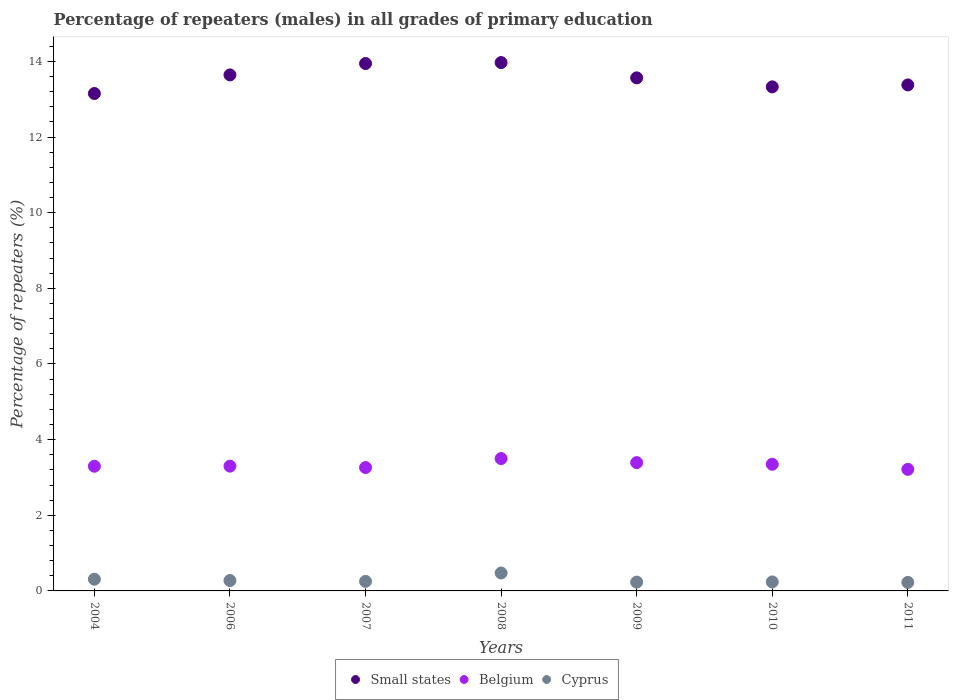What is the percentage of repeaters (males) in Cyprus in 2009?
Offer a very short reply. 0.23. Across all years, what is the maximum percentage of repeaters (males) in Cyprus?
Make the answer very short. 0.47. Across all years, what is the minimum percentage of repeaters (males) in Belgium?
Ensure brevity in your answer.  3.21. In which year was the percentage of repeaters (males) in Belgium maximum?
Offer a terse response. 2008. In which year was the percentage of repeaters (males) in Belgium minimum?
Offer a very short reply. 2011. What is the total percentage of repeaters (males) in Small states in the graph?
Your answer should be very brief. 94.98. What is the difference between the percentage of repeaters (males) in Small states in 2007 and that in 2011?
Your answer should be compact. 0.57. What is the difference between the percentage of repeaters (males) in Cyprus in 2011 and the percentage of repeaters (males) in Belgium in 2009?
Your response must be concise. -3.17. What is the average percentage of repeaters (males) in Cyprus per year?
Offer a terse response. 0.29. In the year 2011, what is the difference between the percentage of repeaters (males) in Cyprus and percentage of repeaters (males) in Belgium?
Give a very brief answer. -2.99. What is the ratio of the percentage of repeaters (males) in Small states in 2004 to that in 2008?
Give a very brief answer. 0.94. What is the difference between the highest and the second highest percentage of repeaters (males) in Belgium?
Ensure brevity in your answer.  0.11. What is the difference between the highest and the lowest percentage of repeaters (males) in Small states?
Offer a very short reply. 0.82. In how many years, is the percentage of repeaters (males) in Belgium greater than the average percentage of repeaters (males) in Belgium taken over all years?
Your response must be concise. 3. Is the sum of the percentage of repeaters (males) in Belgium in 2008 and 2011 greater than the maximum percentage of repeaters (males) in Cyprus across all years?
Offer a very short reply. Yes. Does the percentage of repeaters (males) in Belgium monotonically increase over the years?
Your response must be concise. No. Is the percentage of repeaters (males) in Small states strictly less than the percentage of repeaters (males) in Belgium over the years?
Provide a succinct answer. No. What is the difference between two consecutive major ticks on the Y-axis?
Offer a very short reply. 2. Are the values on the major ticks of Y-axis written in scientific E-notation?
Ensure brevity in your answer.  No. Does the graph contain any zero values?
Ensure brevity in your answer.  No. What is the title of the graph?
Offer a terse response. Percentage of repeaters (males) in all grades of primary education. Does "Mauritania" appear as one of the legend labels in the graph?
Your response must be concise. No. What is the label or title of the Y-axis?
Your answer should be compact. Percentage of repeaters (%). What is the Percentage of repeaters (%) of Small states in 2004?
Your answer should be very brief. 13.15. What is the Percentage of repeaters (%) in Belgium in 2004?
Provide a succinct answer. 3.3. What is the Percentage of repeaters (%) of Cyprus in 2004?
Your answer should be compact. 0.31. What is the Percentage of repeaters (%) of Small states in 2006?
Offer a terse response. 13.64. What is the Percentage of repeaters (%) of Belgium in 2006?
Make the answer very short. 3.3. What is the Percentage of repeaters (%) of Cyprus in 2006?
Provide a short and direct response. 0.27. What is the Percentage of repeaters (%) in Small states in 2007?
Provide a succinct answer. 13.94. What is the Percentage of repeaters (%) of Belgium in 2007?
Your answer should be compact. 3.26. What is the Percentage of repeaters (%) in Cyprus in 2007?
Offer a terse response. 0.25. What is the Percentage of repeaters (%) in Small states in 2008?
Your answer should be very brief. 13.97. What is the Percentage of repeaters (%) of Belgium in 2008?
Ensure brevity in your answer.  3.5. What is the Percentage of repeaters (%) in Cyprus in 2008?
Your answer should be very brief. 0.47. What is the Percentage of repeaters (%) of Small states in 2009?
Offer a very short reply. 13.57. What is the Percentage of repeaters (%) of Belgium in 2009?
Provide a short and direct response. 3.39. What is the Percentage of repeaters (%) of Cyprus in 2009?
Your response must be concise. 0.23. What is the Percentage of repeaters (%) of Small states in 2010?
Your answer should be very brief. 13.33. What is the Percentage of repeaters (%) in Belgium in 2010?
Your answer should be compact. 3.35. What is the Percentage of repeaters (%) of Cyprus in 2010?
Provide a short and direct response. 0.24. What is the Percentage of repeaters (%) of Small states in 2011?
Give a very brief answer. 13.38. What is the Percentage of repeaters (%) in Belgium in 2011?
Offer a very short reply. 3.21. What is the Percentage of repeaters (%) in Cyprus in 2011?
Your answer should be very brief. 0.23. Across all years, what is the maximum Percentage of repeaters (%) in Small states?
Your answer should be very brief. 13.97. Across all years, what is the maximum Percentage of repeaters (%) of Belgium?
Offer a terse response. 3.5. Across all years, what is the maximum Percentage of repeaters (%) in Cyprus?
Your answer should be very brief. 0.47. Across all years, what is the minimum Percentage of repeaters (%) of Small states?
Ensure brevity in your answer.  13.15. Across all years, what is the minimum Percentage of repeaters (%) in Belgium?
Provide a succinct answer. 3.21. Across all years, what is the minimum Percentage of repeaters (%) of Cyprus?
Ensure brevity in your answer.  0.23. What is the total Percentage of repeaters (%) in Small states in the graph?
Ensure brevity in your answer.  94.98. What is the total Percentage of repeaters (%) of Belgium in the graph?
Offer a very short reply. 23.31. What is the total Percentage of repeaters (%) in Cyprus in the graph?
Give a very brief answer. 2.01. What is the difference between the Percentage of repeaters (%) in Small states in 2004 and that in 2006?
Keep it short and to the point. -0.49. What is the difference between the Percentage of repeaters (%) in Belgium in 2004 and that in 2006?
Provide a short and direct response. -0. What is the difference between the Percentage of repeaters (%) in Cyprus in 2004 and that in 2006?
Give a very brief answer. 0.04. What is the difference between the Percentage of repeaters (%) in Small states in 2004 and that in 2007?
Make the answer very short. -0.79. What is the difference between the Percentage of repeaters (%) in Belgium in 2004 and that in 2007?
Give a very brief answer. 0.03. What is the difference between the Percentage of repeaters (%) in Cyprus in 2004 and that in 2007?
Ensure brevity in your answer.  0.06. What is the difference between the Percentage of repeaters (%) of Small states in 2004 and that in 2008?
Give a very brief answer. -0.82. What is the difference between the Percentage of repeaters (%) of Belgium in 2004 and that in 2008?
Provide a short and direct response. -0.2. What is the difference between the Percentage of repeaters (%) of Cyprus in 2004 and that in 2008?
Provide a succinct answer. -0.16. What is the difference between the Percentage of repeaters (%) of Small states in 2004 and that in 2009?
Offer a very short reply. -0.41. What is the difference between the Percentage of repeaters (%) of Belgium in 2004 and that in 2009?
Provide a succinct answer. -0.1. What is the difference between the Percentage of repeaters (%) in Cyprus in 2004 and that in 2009?
Keep it short and to the point. 0.08. What is the difference between the Percentage of repeaters (%) in Small states in 2004 and that in 2010?
Provide a short and direct response. -0.18. What is the difference between the Percentage of repeaters (%) of Belgium in 2004 and that in 2010?
Offer a terse response. -0.05. What is the difference between the Percentage of repeaters (%) of Cyprus in 2004 and that in 2010?
Offer a terse response. 0.07. What is the difference between the Percentage of repeaters (%) in Small states in 2004 and that in 2011?
Your answer should be compact. -0.23. What is the difference between the Percentage of repeaters (%) in Belgium in 2004 and that in 2011?
Your response must be concise. 0.08. What is the difference between the Percentage of repeaters (%) of Cyprus in 2004 and that in 2011?
Your answer should be very brief. 0.08. What is the difference between the Percentage of repeaters (%) of Small states in 2006 and that in 2007?
Offer a terse response. -0.3. What is the difference between the Percentage of repeaters (%) in Belgium in 2006 and that in 2007?
Give a very brief answer. 0.04. What is the difference between the Percentage of repeaters (%) of Cyprus in 2006 and that in 2007?
Make the answer very short. 0.02. What is the difference between the Percentage of repeaters (%) in Small states in 2006 and that in 2008?
Give a very brief answer. -0.33. What is the difference between the Percentage of repeaters (%) in Belgium in 2006 and that in 2008?
Your response must be concise. -0.2. What is the difference between the Percentage of repeaters (%) in Cyprus in 2006 and that in 2008?
Provide a short and direct response. -0.2. What is the difference between the Percentage of repeaters (%) of Small states in 2006 and that in 2009?
Give a very brief answer. 0.08. What is the difference between the Percentage of repeaters (%) of Belgium in 2006 and that in 2009?
Your answer should be very brief. -0.09. What is the difference between the Percentage of repeaters (%) of Cyprus in 2006 and that in 2009?
Your answer should be very brief. 0.04. What is the difference between the Percentage of repeaters (%) in Small states in 2006 and that in 2010?
Ensure brevity in your answer.  0.32. What is the difference between the Percentage of repeaters (%) in Belgium in 2006 and that in 2010?
Keep it short and to the point. -0.05. What is the difference between the Percentage of repeaters (%) of Cyprus in 2006 and that in 2010?
Make the answer very short. 0.04. What is the difference between the Percentage of repeaters (%) in Small states in 2006 and that in 2011?
Provide a succinct answer. 0.27. What is the difference between the Percentage of repeaters (%) of Belgium in 2006 and that in 2011?
Give a very brief answer. 0.08. What is the difference between the Percentage of repeaters (%) of Cyprus in 2006 and that in 2011?
Provide a short and direct response. 0.05. What is the difference between the Percentage of repeaters (%) in Small states in 2007 and that in 2008?
Offer a very short reply. -0.03. What is the difference between the Percentage of repeaters (%) in Belgium in 2007 and that in 2008?
Ensure brevity in your answer.  -0.24. What is the difference between the Percentage of repeaters (%) of Cyprus in 2007 and that in 2008?
Your response must be concise. -0.22. What is the difference between the Percentage of repeaters (%) of Small states in 2007 and that in 2009?
Provide a succinct answer. 0.38. What is the difference between the Percentage of repeaters (%) in Belgium in 2007 and that in 2009?
Keep it short and to the point. -0.13. What is the difference between the Percentage of repeaters (%) in Cyprus in 2007 and that in 2009?
Your answer should be compact. 0.02. What is the difference between the Percentage of repeaters (%) of Small states in 2007 and that in 2010?
Give a very brief answer. 0.62. What is the difference between the Percentage of repeaters (%) of Belgium in 2007 and that in 2010?
Your response must be concise. -0.09. What is the difference between the Percentage of repeaters (%) in Cyprus in 2007 and that in 2010?
Provide a succinct answer. 0.01. What is the difference between the Percentage of repeaters (%) of Small states in 2007 and that in 2011?
Your answer should be very brief. 0.57. What is the difference between the Percentage of repeaters (%) of Belgium in 2007 and that in 2011?
Your answer should be compact. 0.05. What is the difference between the Percentage of repeaters (%) in Cyprus in 2007 and that in 2011?
Keep it short and to the point. 0.03. What is the difference between the Percentage of repeaters (%) in Small states in 2008 and that in 2009?
Ensure brevity in your answer.  0.4. What is the difference between the Percentage of repeaters (%) of Belgium in 2008 and that in 2009?
Ensure brevity in your answer.  0.11. What is the difference between the Percentage of repeaters (%) of Cyprus in 2008 and that in 2009?
Provide a short and direct response. 0.24. What is the difference between the Percentage of repeaters (%) in Small states in 2008 and that in 2010?
Provide a succinct answer. 0.64. What is the difference between the Percentage of repeaters (%) of Belgium in 2008 and that in 2010?
Your response must be concise. 0.15. What is the difference between the Percentage of repeaters (%) in Cyprus in 2008 and that in 2010?
Offer a very short reply. 0.24. What is the difference between the Percentage of repeaters (%) in Small states in 2008 and that in 2011?
Your response must be concise. 0.59. What is the difference between the Percentage of repeaters (%) in Belgium in 2008 and that in 2011?
Your answer should be compact. 0.29. What is the difference between the Percentage of repeaters (%) in Cyprus in 2008 and that in 2011?
Provide a succinct answer. 0.25. What is the difference between the Percentage of repeaters (%) in Small states in 2009 and that in 2010?
Give a very brief answer. 0.24. What is the difference between the Percentage of repeaters (%) of Belgium in 2009 and that in 2010?
Your answer should be compact. 0.04. What is the difference between the Percentage of repeaters (%) of Cyprus in 2009 and that in 2010?
Provide a short and direct response. -0. What is the difference between the Percentage of repeaters (%) of Small states in 2009 and that in 2011?
Offer a very short reply. 0.19. What is the difference between the Percentage of repeaters (%) in Belgium in 2009 and that in 2011?
Your answer should be compact. 0.18. What is the difference between the Percentage of repeaters (%) in Cyprus in 2009 and that in 2011?
Keep it short and to the point. 0.01. What is the difference between the Percentage of repeaters (%) in Small states in 2010 and that in 2011?
Keep it short and to the point. -0.05. What is the difference between the Percentage of repeaters (%) in Belgium in 2010 and that in 2011?
Give a very brief answer. 0.13. What is the difference between the Percentage of repeaters (%) in Cyprus in 2010 and that in 2011?
Your answer should be compact. 0.01. What is the difference between the Percentage of repeaters (%) in Small states in 2004 and the Percentage of repeaters (%) in Belgium in 2006?
Your answer should be very brief. 9.85. What is the difference between the Percentage of repeaters (%) of Small states in 2004 and the Percentage of repeaters (%) of Cyprus in 2006?
Your response must be concise. 12.88. What is the difference between the Percentage of repeaters (%) in Belgium in 2004 and the Percentage of repeaters (%) in Cyprus in 2006?
Provide a short and direct response. 3.02. What is the difference between the Percentage of repeaters (%) in Small states in 2004 and the Percentage of repeaters (%) in Belgium in 2007?
Make the answer very short. 9.89. What is the difference between the Percentage of repeaters (%) of Small states in 2004 and the Percentage of repeaters (%) of Cyprus in 2007?
Your answer should be compact. 12.9. What is the difference between the Percentage of repeaters (%) in Belgium in 2004 and the Percentage of repeaters (%) in Cyprus in 2007?
Offer a terse response. 3.04. What is the difference between the Percentage of repeaters (%) of Small states in 2004 and the Percentage of repeaters (%) of Belgium in 2008?
Provide a succinct answer. 9.65. What is the difference between the Percentage of repeaters (%) of Small states in 2004 and the Percentage of repeaters (%) of Cyprus in 2008?
Your answer should be very brief. 12.68. What is the difference between the Percentage of repeaters (%) of Belgium in 2004 and the Percentage of repeaters (%) of Cyprus in 2008?
Offer a very short reply. 2.82. What is the difference between the Percentage of repeaters (%) of Small states in 2004 and the Percentage of repeaters (%) of Belgium in 2009?
Ensure brevity in your answer.  9.76. What is the difference between the Percentage of repeaters (%) of Small states in 2004 and the Percentage of repeaters (%) of Cyprus in 2009?
Offer a terse response. 12.92. What is the difference between the Percentage of repeaters (%) in Belgium in 2004 and the Percentage of repeaters (%) in Cyprus in 2009?
Offer a terse response. 3.06. What is the difference between the Percentage of repeaters (%) in Small states in 2004 and the Percentage of repeaters (%) in Belgium in 2010?
Your answer should be very brief. 9.8. What is the difference between the Percentage of repeaters (%) in Small states in 2004 and the Percentage of repeaters (%) in Cyprus in 2010?
Your answer should be compact. 12.91. What is the difference between the Percentage of repeaters (%) in Belgium in 2004 and the Percentage of repeaters (%) in Cyprus in 2010?
Give a very brief answer. 3.06. What is the difference between the Percentage of repeaters (%) in Small states in 2004 and the Percentage of repeaters (%) in Belgium in 2011?
Make the answer very short. 9.94. What is the difference between the Percentage of repeaters (%) in Small states in 2004 and the Percentage of repeaters (%) in Cyprus in 2011?
Your response must be concise. 12.93. What is the difference between the Percentage of repeaters (%) in Belgium in 2004 and the Percentage of repeaters (%) in Cyprus in 2011?
Your answer should be compact. 3.07. What is the difference between the Percentage of repeaters (%) in Small states in 2006 and the Percentage of repeaters (%) in Belgium in 2007?
Keep it short and to the point. 10.38. What is the difference between the Percentage of repeaters (%) in Small states in 2006 and the Percentage of repeaters (%) in Cyprus in 2007?
Offer a very short reply. 13.39. What is the difference between the Percentage of repeaters (%) in Belgium in 2006 and the Percentage of repeaters (%) in Cyprus in 2007?
Keep it short and to the point. 3.05. What is the difference between the Percentage of repeaters (%) in Small states in 2006 and the Percentage of repeaters (%) in Belgium in 2008?
Your response must be concise. 10.14. What is the difference between the Percentage of repeaters (%) of Small states in 2006 and the Percentage of repeaters (%) of Cyprus in 2008?
Keep it short and to the point. 13.17. What is the difference between the Percentage of repeaters (%) of Belgium in 2006 and the Percentage of repeaters (%) of Cyprus in 2008?
Keep it short and to the point. 2.82. What is the difference between the Percentage of repeaters (%) of Small states in 2006 and the Percentage of repeaters (%) of Belgium in 2009?
Your answer should be very brief. 10.25. What is the difference between the Percentage of repeaters (%) in Small states in 2006 and the Percentage of repeaters (%) in Cyprus in 2009?
Offer a terse response. 13.41. What is the difference between the Percentage of repeaters (%) in Belgium in 2006 and the Percentage of repeaters (%) in Cyprus in 2009?
Your answer should be very brief. 3.07. What is the difference between the Percentage of repeaters (%) of Small states in 2006 and the Percentage of repeaters (%) of Belgium in 2010?
Offer a very short reply. 10.29. What is the difference between the Percentage of repeaters (%) of Small states in 2006 and the Percentage of repeaters (%) of Cyprus in 2010?
Your answer should be compact. 13.41. What is the difference between the Percentage of repeaters (%) of Belgium in 2006 and the Percentage of repeaters (%) of Cyprus in 2010?
Your answer should be very brief. 3.06. What is the difference between the Percentage of repeaters (%) in Small states in 2006 and the Percentage of repeaters (%) in Belgium in 2011?
Your response must be concise. 10.43. What is the difference between the Percentage of repeaters (%) of Small states in 2006 and the Percentage of repeaters (%) of Cyprus in 2011?
Ensure brevity in your answer.  13.42. What is the difference between the Percentage of repeaters (%) of Belgium in 2006 and the Percentage of repeaters (%) of Cyprus in 2011?
Provide a short and direct response. 3.07. What is the difference between the Percentage of repeaters (%) of Small states in 2007 and the Percentage of repeaters (%) of Belgium in 2008?
Make the answer very short. 10.44. What is the difference between the Percentage of repeaters (%) of Small states in 2007 and the Percentage of repeaters (%) of Cyprus in 2008?
Give a very brief answer. 13.47. What is the difference between the Percentage of repeaters (%) in Belgium in 2007 and the Percentage of repeaters (%) in Cyprus in 2008?
Provide a short and direct response. 2.79. What is the difference between the Percentage of repeaters (%) in Small states in 2007 and the Percentage of repeaters (%) in Belgium in 2009?
Ensure brevity in your answer.  10.55. What is the difference between the Percentage of repeaters (%) of Small states in 2007 and the Percentage of repeaters (%) of Cyprus in 2009?
Your answer should be very brief. 13.71. What is the difference between the Percentage of repeaters (%) of Belgium in 2007 and the Percentage of repeaters (%) of Cyprus in 2009?
Offer a very short reply. 3.03. What is the difference between the Percentage of repeaters (%) of Small states in 2007 and the Percentage of repeaters (%) of Belgium in 2010?
Offer a terse response. 10.6. What is the difference between the Percentage of repeaters (%) in Small states in 2007 and the Percentage of repeaters (%) in Cyprus in 2010?
Your answer should be very brief. 13.71. What is the difference between the Percentage of repeaters (%) in Belgium in 2007 and the Percentage of repeaters (%) in Cyprus in 2010?
Your response must be concise. 3.02. What is the difference between the Percentage of repeaters (%) in Small states in 2007 and the Percentage of repeaters (%) in Belgium in 2011?
Provide a short and direct response. 10.73. What is the difference between the Percentage of repeaters (%) of Small states in 2007 and the Percentage of repeaters (%) of Cyprus in 2011?
Ensure brevity in your answer.  13.72. What is the difference between the Percentage of repeaters (%) in Belgium in 2007 and the Percentage of repeaters (%) in Cyprus in 2011?
Ensure brevity in your answer.  3.04. What is the difference between the Percentage of repeaters (%) in Small states in 2008 and the Percentage of repeaters (%) in Belgium in 2009?
Offer a very short reply. 10.58. What is the difference between the Percentage of repeaters (%) of Small states in 2008 and the Percentage of repeaters (%) of Cyprus in 2009?
Make the answer very short. 13.74. What is the difference between the Percentage of repeaters (%) of Belgium in 2008 and the Percentage of repeaters (%) of Cyprus in 2009?
Give a very brief answer. 3.27. What is the difference between the Percentage of repeaters (%) in Small states in 2008 and the Percentage of repeaters (%) in Belgium in 2010?
Give a very brief answer. 10.62. What is the difference between the Percentage of repeaters (%) of Small states in 2008 and the Percentage of repeaters (%) of Cyprus in 2010?
Ensure brevity in your answer.  13.73. What is the difference between the Percentage of repeaters (%) in Belgium in 2008 and the Percentage of repeaters (%) in Cyprus in 2010?
Your answer should be compact. 3.26. What is the difference between the Percentage of repeaters (%) in Small states in 2008 and the Percentage of repeaters (%) in Belgium in 2011?
Your answer should be compact. 10.76. What is the difference between the Percentage of repeaters (%) in Small states in 2008 and the Percentage of repeaters (%) in Cyprus in 2011?
Your answer should be compact. 13.74. What is the difference between the Percentage of repeaters (%) of Belgium in 2008 and the Percentage of repeaters (%) of Cyprus in 2011?
Provide a succinct answer. 3.28. What is the difference between the Percentage of repeaters (%) in Small states in 2009 and the Percentage of repeaters (%) in Belgium in 2010?
Provide a succinct answer. 10.22. What is the difference between the Percentage of repeaters (%) of Small states in 2009 and the Percentage of repeaters (%) of Cyprus in 2010?
Offer a terse response. 13.33. What is the difference between the Percentage of repeaters (%) in Belgium in 2009 and the Percentage of repeaters (%) in Cyprus in 2010?
Offer a terse response. 3.15. What is the difference between the Percentage of repeaters (%) in Small states in 2009 and the Percentage of repeaters (%) in Belgium in 2011?
Keep it short and to the point. 10.35. What is the difference between the Percentage of repeaters (%) of Small states in 2009 and the Percentage of repeaters (%) of Cyprus in 2011?
Give a very brief answer. 13.34. What is the difference between the Percentage of repeaters (%) of Belgium in 2009 and the Percentage of repeaters (%) of Cyprus in 2011?
Give a very brief answer. 3.17. What is the difference between the Percentage of repeaters (%) of Small states in 2010 and the Percentage of repeaters (%) of Belgium in 2011?
Keep it short and to the point. 10.11. What is the difference between the Percentage of repeaters (%) in Small states in 2010 and the Percentage of repeaters (%) in Cyprus in 2011?
Keep it short and to the point. 13.1. What is the difference between the Percentage of repeaters (%) in Belgium in 2010 and the Percentage of repeaters (%) in Cyprus in 2011?
Your response must be concise. 3.12. What is the average Percentage of repeaters (%) of Small states per year?
Give a very brief answer. 13.57. What is the average Percentage of repeaters (%) of Belgium per year?
Ensure brevity in your answer.  3.33. What is the average Percentage of repeaters (%) in Cyprus per year?
Provide a succinct answer. 0.29. In the year 2004, what is the difference between the Percentage of repeaters (%) of Small states and Percentage of repeaters (%) of Belgium?
Your answer should be very brief. 9.86. In the year 2004, what is the difference between the Percentage of repeaters (%) of Small states and Percentage of repeaters (%) of Cyprus?
Your answer should be very brief. 12.84. In the year 2004, what is the difference between the Percentage of repeaters (%) of Belgium and Percentage of repeaters (%) of Cyprus?
Your answer should be very brief. 2.99. In the year 2006, what is the difference between the Percentage of repeaters (%) of Small states and Percentage of repeaters (%) of Belgium?
Your answer should be compact. 10.34. In the year 2006, what is the difference between the Percentage of repeaters (%) in Small states and Percentage of repeaters (%) in Cyprus?
Your answer should be compact. 13.37. In the year 2006, what is the difference between the Percentage of repeaters (%) in Belgium and Percentage of repeaters (%) in Cyprus?
Make the answer very short. 3.02. In the year 2007, what is the difference between the Percentage of repeaters (%) of Small states and Percentage of repeaters (%) of Belgium?
Offer a very short reply. 10.68. In the year 2007, what is the difference between the Percentage of repeaters (%) in Small states and Percentage of repeaters (%) in Cyprus?
Your answer should be very brief. 13.69. In the year 2007, what is the difference between the Percentage of repeaters (%) of Belgium and Percentage of repeaters (%) of Cyprus?
Provide a short and direct response. 3.01. In the year 2008, what is the difference between the Percentage of repeaters (%) in Small states and Percentage of repeaters (%) in Belgium?
Offer a terse response. 10.47. In the year 2008, what is the difference between the Percentage of repeaters (%) in Small states and Percentage of repeaters (%) in Cyprus?
Your answer should be compact. 13.5. In the year 2008, what is the difference between the Percentage of repeaters (%) of Belgium and Percentage of repeaters (%) of Cyprus?
Provide a succinct answer. 3.03. In the year 2009, what is the difference between the Percentage of repeaters (%) of Small states and Percentage of repeaters (%) of Belgium?
Keep it short and to the point. 10.17. In the year 2009, what is the difference between the Percentage of repeaters (%) in Small states and Percentage of repeaters (%) in Cyprus?
Your answer should be very brief. 13.33. In the year 2009, what is the difference between the Percentage of repeaters (%) of Belgium and Percentage of repeaters (%) of Cyprus?
Your response must be concise. 3.16. In the year 2010, what is the difference between the Percentage of repeaters (%) in Small states and Percentage of repeaters (%) in Belgium?
Make the answer very short. 9.98. In the year 2010, what is the difference between the Percentage of repeaters (%) of Small states and Percentage of repeaters (%) of Cyprus?
Keep it short and to the point. 13.09. In the year 2010, what is the difference between the Percentage of repeaters (%) of Belgium and Percentage of repeaters (%) of Cyprus?
Make the answer very short. 3.11. In the year 2011, what is the difference between the Percentage of repeaters (%) in Small states and Percentage of repeaters (%) in Belgium?
Your answer should be compact. 10.16. In the year 2011, what is the difference between the Percentage of repeaters (%) of Small states and Percentage of repeaters (%) of Cyprus?
Your answer should be compact. 13.15. In the year 2011, what is the difference between the Percentage of repeaters (%) of Belgium and Percentage of repeaters (%) of Cyprus?
Give a very brief answer. 2.99. What is the ratio of the Percentage of repeaters (%) of Small states in 2004 to that in 2006?
Make the answer very short. 0.96. What is the ratio of the Percentage of repeaters (%) in Cyprus in 2004 to that in 2006?
Ensure brevity in your answer.  1.13. What is the ratio of the Percentage of repeaters (%) of Small states in 2004 to that in 2007?
Make the answer very short. 0.94. What is the ratio of the Percentage of repeaters (%) of Belgium in 2004 to that in 2007?
Your response must be concise. 1.01. What is the ratio of the Percentage of repeaters (%) in Cyprus in 2004 to that in 2007?
Provide a short and direct response. 1.23. What is the ratio of the Percentage of repeaters (%) of Small states in 2004 to that in 2008?
Keep it short and to the point. 0.94. What is the ratio of the Percentage of repeaters (%) in Belgium in 2004 to that in 2008?
Your response must be concise. 0.94. What is the ratio of the Percentage of repeaters (%) in Cyprus in 2004 to that in 2008?
Offer a terse response. 0.65. What is the ratio of the Percentage of repeaters (%) in Small states in 2004 to that in 2009?
Keep it short and to the point. 0.97. What is the ratio of the Percentage of repeaters (%) of Belgium in 2004 to that in 2009?
Make the answer very short. 0.97. What is the ratio of the Percentage of repeaters (%) of Cyprus in 2004 to that in 2009?
Keep it short and to the point. 1.33. What is the ratio of the Percentage of repeaters (%) of Belgium in 2004 to that in 2010?
Give a very brief answer. 0.98. What is the ratio of the Percentage of repeaters (%) of Cyprus in 2004 to that in 2010?
Provide a short and direct response. 1.3. What is the ratio of the Percentage of repeaters (%) in Small states in 2004 to that in 2011?
Your response must be concise. 0.98. What is the ratio of the Percentage of repeaters (%) of Belgium in 2004 to that in 2011?
Ensure brevity in your answer.  1.03. What is the ratio of the Percentage of repeaters (%) in Cyprus in 2004 to that in 2011?
Your response must be concise. 1.38. What is the ratio of the Percentage of repeaters (%) of Small states in 2006 to that in 2007?
Your answer should be very brief. 0.98. What is the ratio of the Percentage of repeaters (%) of Belgium in 2006 to that in 2007?
Provide a succinct answer. 1.01. What is the ratio of the Percentage of repeaters (%) in Cyprus in 2006 to that in 2007?
Keep it short and to the point. 1.09. What is the ratio of the Percentage of repeaters (%) in Small states in 2006 to that in 2008?
Offer a terse response. 0.98. What is the ratio of the Percentage of repeaters (%) of Belgium in 2006 to that in 2008?
Offer a very short reply. 0.94. What is the ratio of the Percentage of repeaters (%) of Cyprus in 2006 to that in 2008?
Your answer should be very brief. 0.58. What is the ratio of the Percentage of repeaters (%) in Small states in 2006 to that in 2009?
Make the answer very short. 1.01. What is the ratio of the Percentage of repeaters (%) of Belgium in 2006 to that in 2009?
Offer a very short reply. 0.97. What is the ratio of the Percentage of repeaters (%) in Cyprus in 2006 to that in 2009?
Ensure brevity in your answer.  1.18. What is the ratio of the Percentage of repeaters (%) in Small states in 2006 to that in 2010?
Offer a terse response. 1.02. What is the ratio of the Percentage of repeaters (%) in Belgium in 2006 to that in 2010?
Your response must be concise. 0.99. What is the ratio of the Percentage of repeaters (%) of Cyprus in 2006 to that in 2010?
Offer a very short reply. 1.15. What is the ratio of the Percentage of repeaters (%) in Small states in 2006 to that in 2011?
Keep it short and to the point. 1.02. What is the ratio of the Percentage of repeaters (%) in Belgium in 2006 to that in 2011?
Offer a very short reply. 1.03. What is the ratio of the Percentage of repeaters (%) of Cyprus in 2006 to that in 2011?
Offer a terse response. 1.22. What is the ratio of the Percentage of repeaters (%) in Belgium in 2007 to that in 2008?
Keep it short and to the point. 0.93. What is the ratio of the Percentage of repeaters (%) of Cyprus in 2007 to that in 2008?
Your answer should be very brief. 0.53. What is the ratio of the Percentage of repeaters (%) in Small states in 2007 to that in 2009?
Offer a very short reply. 1.03. What is the ratio of the Percentage of repeaters (%) in Belgium in 2007 to that in 2009?
Offer a very short reply. 0.96. What is the ratio of the Percentage of repeaters (%) of Cyprus in 2007 to that in 2009?
Give a very brief answer. 1.08. What is the ratio of the Percentage of repeaters (%) in Small states in 2007 to that in 2010?
Offer a very short reply. 1.05. What is the ratio of the Percentage of repeaters (%) of Belgium in 2007 to that in 2010?
Give a very brief answer. 0.97. What is the ratio of the Percentage of repeaters (%) in Cyprus in 2007 to that in 2010?
Keep it short and to the point. 1.06. What is the ratio of the Percentage of repeaters (%) of Small states in 2007 to that in 2011?
Offer a terse response. 1.04. What is the ratio of the Percentage of repeaters (%) of Belgium in 2007 to that in 2011?
Make the answer very short. 1.01. What is the ratio of the Percentage of repeaters (%) of Cyprus in 2007 to that in 2011?
Offer a terse response. 1.12. What is the ratio of the Percentage of repeaters (%) of Small states in 2008 to that in 2009?
Offer a terse response. 1.03. What is the ratio of the Percentage of repeaters (%) in Belgium in 2008 to that in 2009?
Give a very brief answer. 1.03. What is the ratio of the Percentage of repeaters (%) of Cyprus in 2008 to that in 2009?
Provide a succinct answer. 2.03. What is the ratio of the Percentage of repeaters (%) of Small states in 2008 to that in 2010?
Keep it short and to the point. 1.05. What is the ratio of the Percentage of repeaters (%) in Belgium in 2008 to that in 2010?
Ensure brevity in your answer.  1.05. What is the ratio of the Percentage of repeaters (%) in Cyprus in 2008 to that in 2010?
Make the answer very short. 1.99. What is the ratio of the Percentage of repeaters (%) of Small states in 2008 to that in 2011?
Provide a short and direct response. 1.04. What is the ratio of the Percentage of repeaters (%) in Belgium in 2008 to that in 2011?
Your answer should be very brief. 1.09. What is the ratio of the Percentage of repeaters (%) in Cyprus in 2008 to that in 2011?
Your answer should be compact. 2.11. What is the ratio of the Percentage of repeaters (%) of Small states in 2009 to that in 2010?
Make the answer very short. 1.02. What is the ratio of the Percentage of repeaters (%) in Cyprus in 2009 to that in 2010?
Your answer should be very brief. 0.98. What is the ratio of the Percentage of repeaters (%) of Small states in 2009 to that in 2011?
Offer a very short reply. 1.01. What is the ratio of the Percentage of repeaters (%) in Belgium in 2009 to that in 2011?
Make the answer very short. 1.06. What is the ratio of the Percentage of repeaters (%) of Cyprus in 2009 to that in 2011?
Offer a terse response. 1.04. What is the ratio of the Percentage of repeaters (%) of Small states in 2010 to that in 2011?
Ensure brevity in your answer.  1. What is the ratio of the Percentage of repeaters (%) of Belgium in 2010 to that in 2011?
Make the answer very short. 1.04. What is the ratio of the Percentage of repeaters (%) in Cyprus in 2010 to that in 2011?
Your answer should be compact. 1.06. What is the difference between the highest and the second highest Percentage of repeaters (%) of Small states?
Provide a succinct answer. 0.03. What is the difference between the highest and the second highest Percentage of repeaters (%) in Belgium?
Your answer should be very brief. 0.11. What is the difference between the highest and the second highest Percentage of repeaters (%) in Cyprus?
Provide a succinct answer. 0.16. What is the difference between the highest and the lowest Percentage of repeaters (%) of Small states?
Provide a short and direct response. 0.82. What is the difference between the highest and the lowest Percentage of repeaters (%) of Belgium?
Give a very brief answer. 0.29. What is the difference between the highest and the lowest Percentage of repeaters (%) of Cyprus?
Your response must be concise. 0.25. 